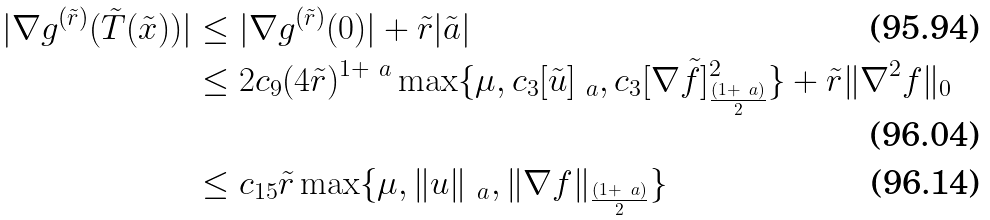Convert formula to latex. <formula><loc_0><loc_0><loc_500><loc_500>| \nabla g ^ { ( \tilde { r } ) } ( \tilde { T } ( \tilde { x } ) ) | & \leq | \nabla g ^ { ( \tilde { r } ) } ( 0 ) | + \tilde { r } | \tilde { a } | \\ & \leq 2 c _ { 9 } ( 4 \tilde { r } ) ^ { 1 + \ a } \max \{ \mu , c _ { 3 } [ \tilde { u } ] _ { \ a } , c _ { 3 } [ \nabla \tilde { f } ] ^ { 2 } _ { \frac { ( 1 + \ a ) } { 2 } } \} + \tilde { r } \| \nabla ^ { 2 } f \| _ { 0 } \\ & \leq c _ { 1 5 } \tilde { r } \max \{ \mu , \| u \| _ { \ a } , \| \nabla f \| _ { \frac { ( 1 + \ a ) } { 2 } } \}</formula> 